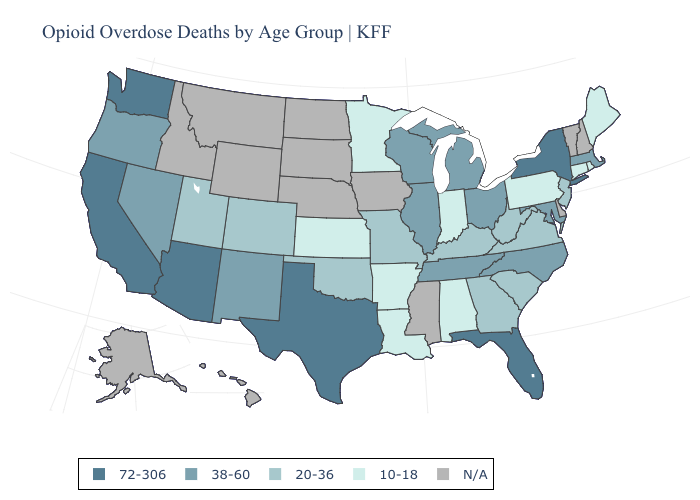What is the lowest value in the USA?
Answer briefly. 10-18. Which states have the lowest value in the West?
Concise answer only. Colorado, Utah. What is the highest value in the Northeast ?
Write a very short answer. 72-306. Name the states that have a value in the range 38-60?
Short answer required. Illinois, Maryland, Massachusetts, Michigan, Nevada, New Mexico, North Carolina, Ohio, Oregon, Tennessee, Wisconsin. What is the value of Colorado?
Short answer required. 20-36. Does New York have the lowest value in the USA?
Give a very brief answer. No. Name the states that have a value in the range 38-60?
Answer briefly. Illinois, Maryland, Massachusetts, Michigan, Nevada, New Mexico, North Carolina, Ohio, Oregon, Tennessee, Wisconsin. Name the states that have a value in the range 10-18?
Quick response, please. Alabama, Arkansas, Connecticut, Indiana, Kansas, Louisiana, Maine, Minnesota, Pennsylvania, Rhode Island. Does the first symbol in the legend represent the smallest category?
Quick response, please. No. What is the value of South Dakota?
Concise answer only. N/A. Name the states that have a value in the range N/A?
Give a very brief answer. Alaska, Delaware, Hawaii, Idaho, Iowa, Mississippi, Montana, Nebraska, New Hampshire, North Dakota, South Dakota, Vermont, Wyoming. Does the first symbol in the legend represent the smallest category?
Short answer required. No. Does Louisiana have the lowest value in the South?
Short answer required. Yes. Does the map have missing data?
Be succinct. Yes. 